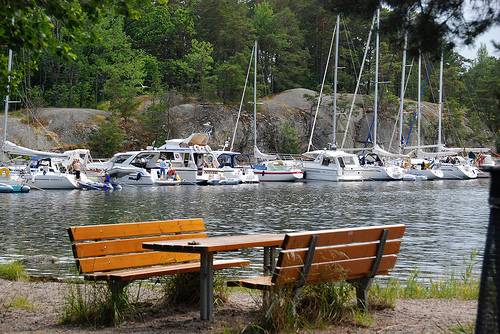<image>
Can you confirm if the picnic table is under the sail boat? No. The picnic table is not positioned under the sail boat. The vertical relationship between these objects is different. Where is the picnic table in relation to the water? Is it next to the water? Yes. The picnic table is positioned adjacent to the water, located nearby in the same general area. 